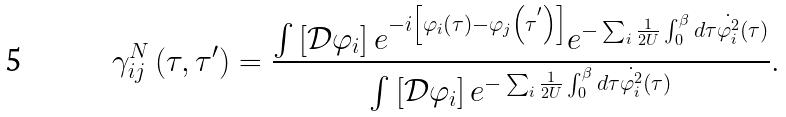<formula> <loc_0><loc_0><loc_500><loc_500>\gamma _ { i j } ^ { N } \left ( \tau , \tau ^ { \prime } \right ) = \frac { \int \left [ \mathcal { D } \varphi _ { i } \right ] e ^ { - i \left [ \varphi _ { i } \left ( \tau \right ) - \varphi _ { j } \left ( \tau ^ { ^ { \prime } } \right ) \right ] } e ^ { - \sum _ { i } \frac { 1 } { 2 U } \int _ { 0 } ^ { \beta } d \tau \dot { \varphi _ { i } ^ { 2 } } \left ( \tau \right ) } } { \int \left [ \mathcal { D } \varphi _ { i } \right ] e ^ { - \sum _ { i } \frac { 1 } { 2 U } \int _ { 0 } ^ { \beta } d \tau \dot { \varphi _ { i } ^ { 2 } } \left ( \tau \right ) } } .</formula> 